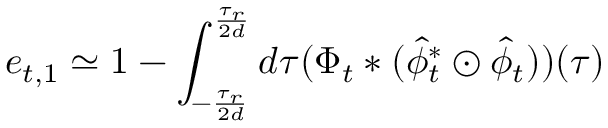<formula> <loc_0><loc_0><loc_500><loc_500>e _ { t , 1 } \simeq 1 - \int _ { - \frac { \tau _ { r } } { 2 d } } ^ { \frac { \tau _ { r } } { 2 d } } d \tau ( \Phi _ { t } * ( \hat { \phi } _ { t } ^ { * } \odot \hat { \phi } _ { t } ) ) ( \tau )</formula> 